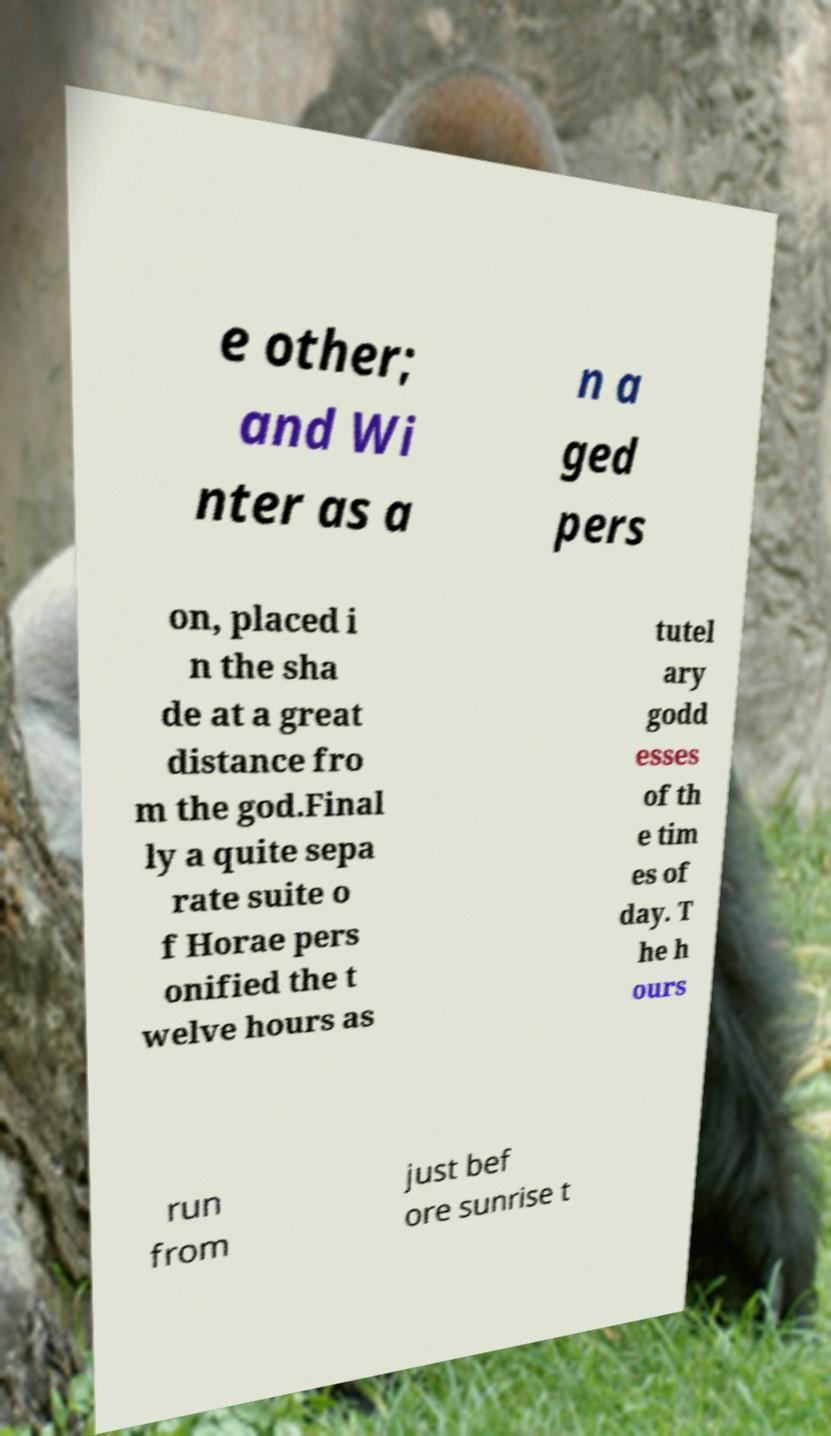For documentation purposes, I need the text within this image transcribed. Could you provide that? e other; and Wi nter as a n a ged pers on, placed i n the sha de at a great distance fro m the god.Final ly a quite sepa rate suite o f Horae pers onified the t welve hours as tutel ary godd esses of th e tim es of day. T he h ours run from just bef ore sunrise t 